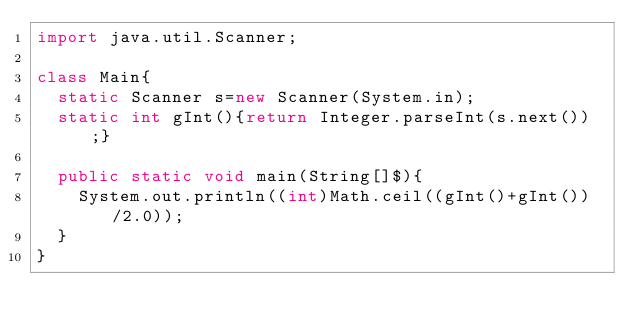Convert code to text. <code><loc_0><loc_0><loc_500><loc_500><_Java_>import java.util.Scanner;

class Main{
	static Scanner s=new Scanner(System.in);
	static int gInt(){return Integer.parseInt(s.next());}

	public static void main(String[]$){
		System.out.println((int)Math.ceil((gInt()+gInt())/2.0));
	}
}</code> 